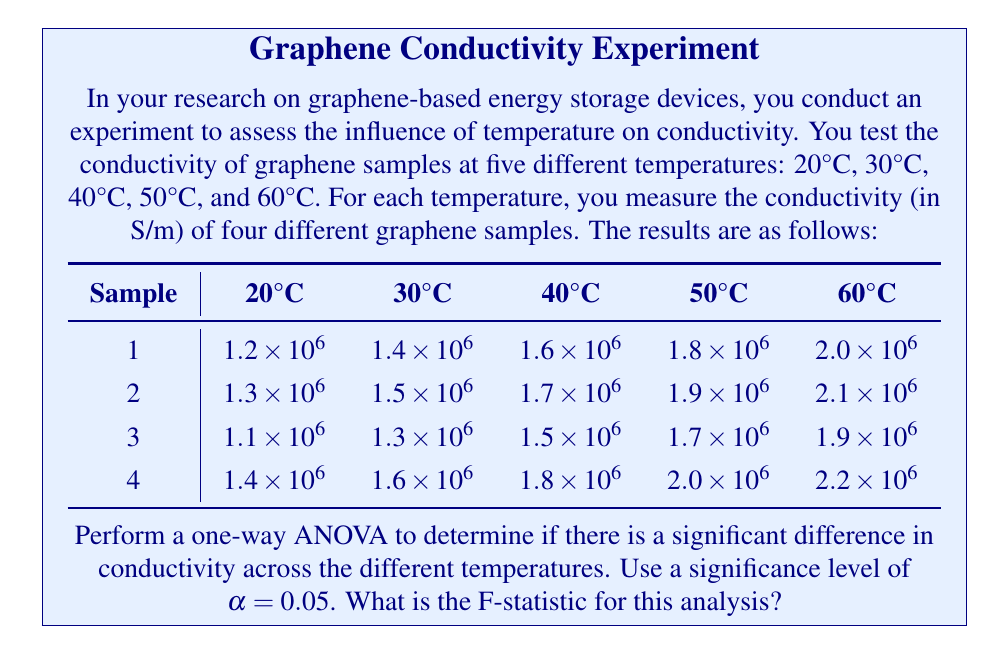Could you help me with this problem? To perform a one-way ANOVA, we need to calculate the following:

1. Grand mean
2. Sum of Squares Total (SST)
3. Sum of Squares Between (SSB)
4. Sum of Squares Within (SSW)
5. Degrees of freedom
6. Mean Square Between (MSB)
7. Mean Square Within (MSW)
8. F-statistic

Step 1: Calculate the grand mean
Grand mean = $\frac{\text{Sum of all observations}}{\text{Total number of observations}}$
$= \frac{75.0 \times 10^6}{20} = 3.75 \times 10^6$

Step 2: Calculate SST
SST = $\sum_{i=1}^{n} (x_i - \bar{x})^2$, where $x_i$ are individual observations and $\bar{x}$ is the grand mean.
SST = $2.89 \times 10^{12}$

Step 3: Calculate SSB
SSB = $\sum_{i=1}^{k} n_i(\bar{x_i} - \bar{x})^2$, where $\bar{x_i}$ are group means, $n_i$ are group sizes, and $k$ is the number of groups.
SSB = $2.80 \times 10^{12}$

Step 4: Calculate SSW
SSW = SST - SSB = $2.89 \times 10^{12} - 2.80 \times 10^{12} = 0.09 \times 10^{12}$

Step 5: Determine degrees of freedom
df_between = k - 1 = 5 - 1 = 4
df_within = N - k = 20 - 5 = 15
df_total = N - 1 = 20 - 1 = 19

Step 6: Calculate MSB
MSB = $\frac{\text{SSB}}{\text{df}_\text{between}} = \frac{2.80 \times 10^{12}}{4} = 0.70 \times 10^{12}$

Step 7: Calculate MSW
MSW = $\frac{\text{SSW}}{\text{df}_\text{within}} = \frac{0.09 \times 10^{12}}{15} = 0.006 \times 10^{12}$

Step 8: Calculate F-statistic
F = $\frac{\text{MSB}}{\text{MSW}} = \frac{0.70 \times 10^{12}}{0.006 \times 10^{12}} = 116.67$
Answer: The F-statistic for this one-way ANOVA is 116.67. 